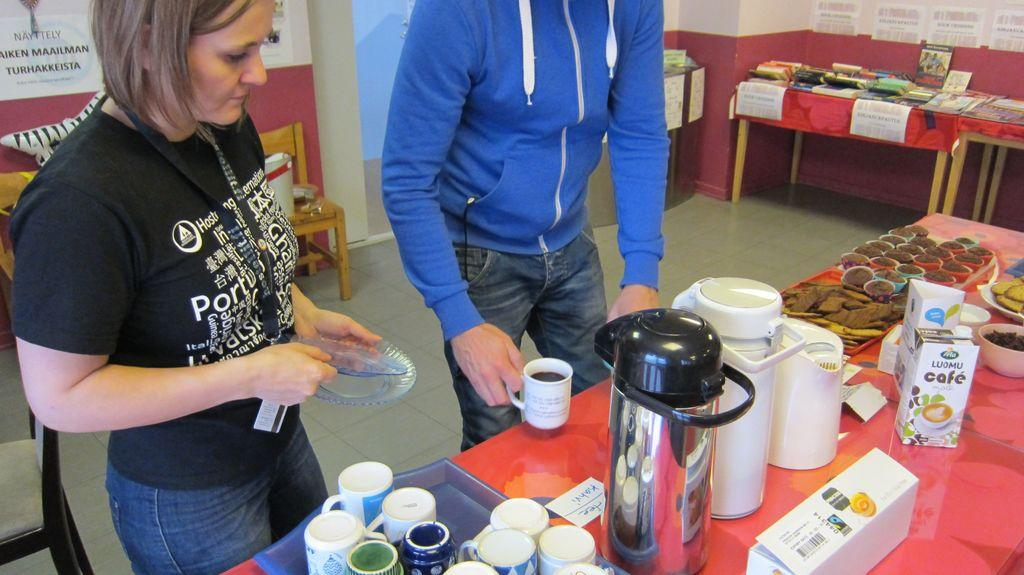<image>
Provide a brief description of the given image. two people in front of a table with a carton that says 'cafe' on it 